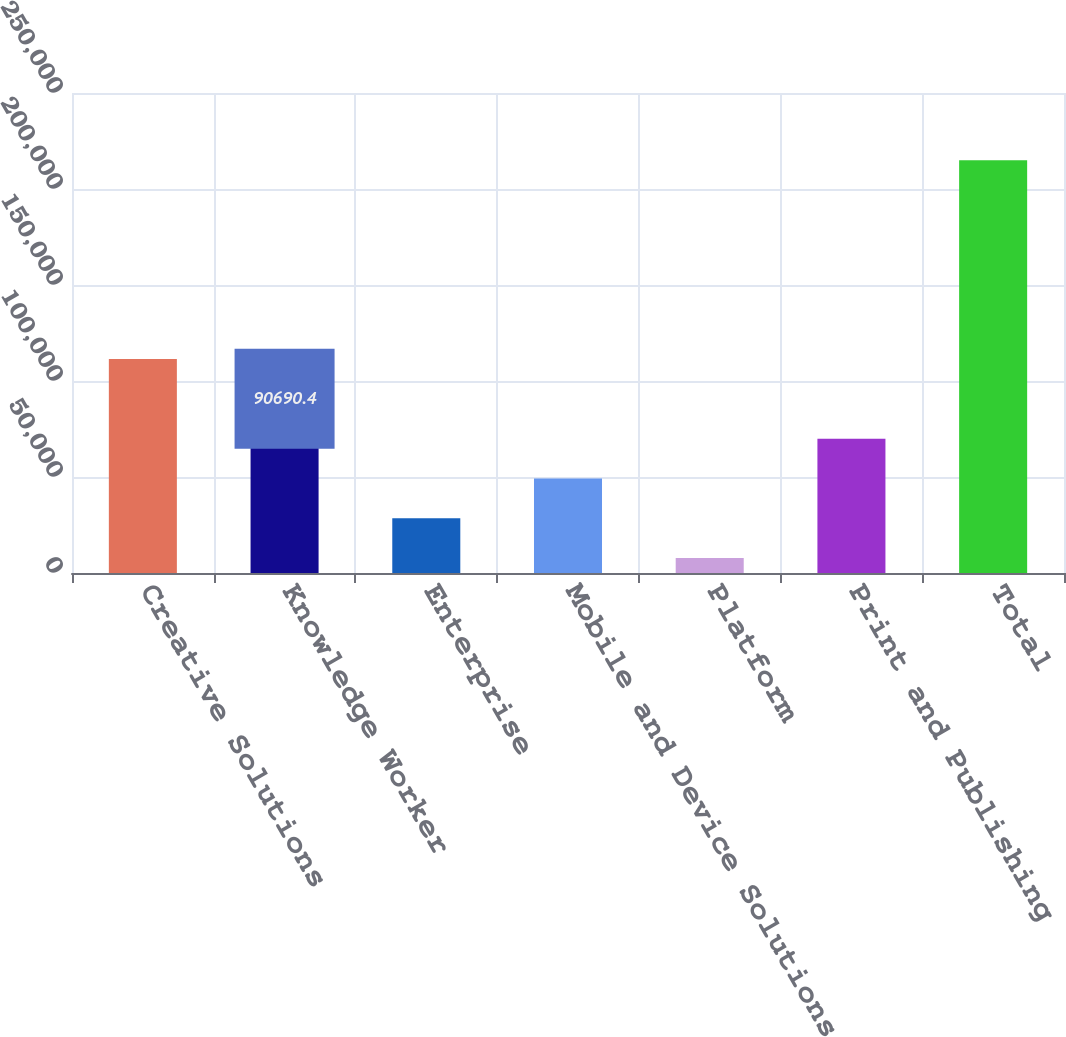<chart> <loc_0><loc_0><loc_500><loc_500><bar_chart><fcel>Creative Solutions<fcel>Knowledge Worker<fcel>Enterprise<fcel>Mobile and Device Solutions<fcel>Platform<fcel>Print and Publishing<fcel>Total<nl><fcel>111402<fcel>90690.4<fcel>28555.6<fcel>49267.2<fcel>7844<fcel>69978.8<fcel>214960<nl></chart> 